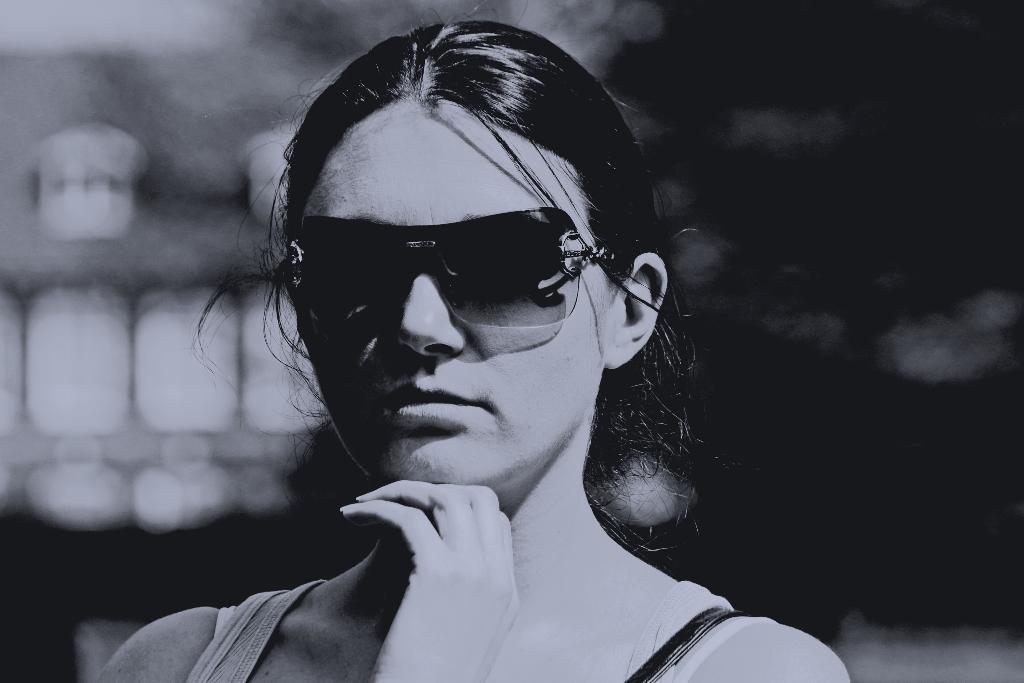What is the color scheme of the image? The image is black and white. Who is present in the image? There is a woman in the image. What is the woman wearing? The woman is wearing goggles. What is the woman doing in the image? The woman is looking at a picture. How is the background of the image depicted? The background of the image is blurred. What type of fuel is being used by the woman in the image? There is no indication of any fuel being used in the image, as it features a woman wearing goggles and looking at a picture. How much dirt can be seen on the woman's hands in the image? There is no dirt visible on the woman's hands in the image, as the focus is on her goggles and the picture she is looking at. 